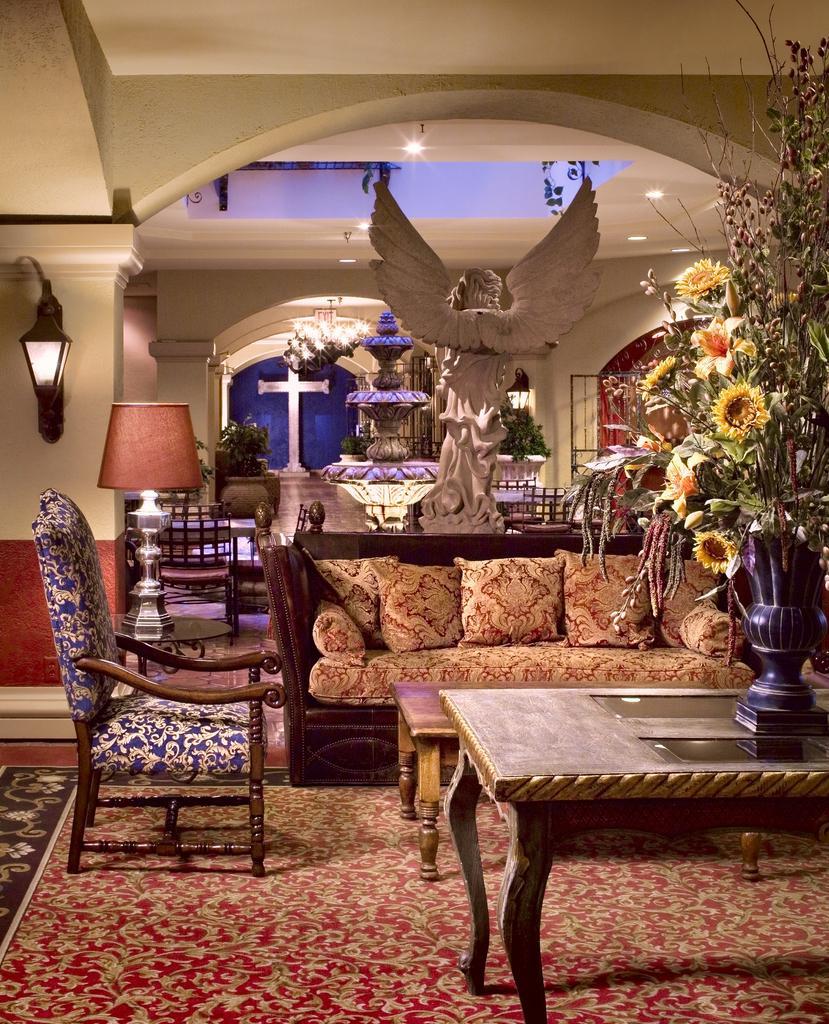Could you give a brief overview of what you see in this image? There is a sofa and table on the right side of the room. There is a chair on the left side of the room. We can see in the background lamp,wall,statue ,lights. 